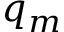Convert formula to latex. <formula><loc_0><loc_0><loc_500><loc_500>q _ { m }</formula> 